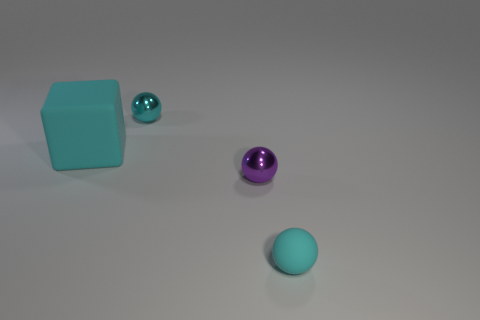Are there any other things that are the same color as the matte sphere?
Provide a short and direct response. Yes. What is the material of the small cyan sphere behind the matte object that is behind the small rubber thing?
Ensure brevity in your answer.  Metal. Are there any purple metallic things that have the same shape as the small rubber thing?
Your response must be concise. Yes. How many other things are there of the same shape as the large cyan thing?
Your answer should be very brief. 0. There is a object that is on the right side of the big cyan thing and behind the purple metallic ball; what is its shape?
Provide a succinct answer. Sphere. There is a cyan sphere that is on the left side of the purple sphere; how big is it?
Your response must be concise. Small. Is the size of the block the same as the matte sphere?
Make the answer very short. No. Are there fewer rubber cubes in front of the big cyan matte cube than cyan rubber objects that are to the right of the tiny purple metallic thing?
Offer a terse response. Yes. There is a thing that is to the left of the tiny rubber thing and in front of the large block; what is its size?
Provide a succinct answer. Small. There is a tiny metallic sphere to the right of the cyan ball that is behind the small matte object; is there a metallic object to the right of it?
Offer a terse response. No. 